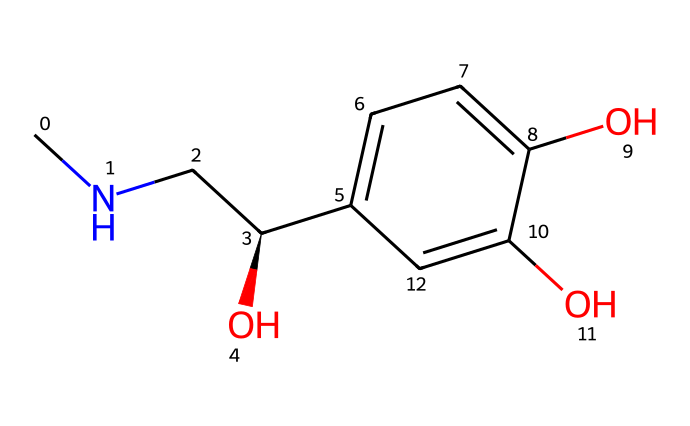What is the full name of this chiral compound? The chemical is adrenaline, also known as epinephrine, which is indicated by the presence of the amine group (CNC) and the hydroxyl groups on the aromatic ring.
Answer: adrenaline How many chiral centers are present in the chemical structure? The structure features one chiral center, which is marked by the carbon atom connected to the amine, hydroxyl, and neighboring carbon atoms (C[C@H]).
Answer: one What type of functional groups are present in this compound? The compound includes an alcohol (hydroxyl) group and an amine group, which are indicated by the –OH and –NH2 portions in the structure.
Answer: hydroxyl and amine What is the molecular formula derived from the structure? By analyzing the number of each atom present in the SMILES, we find it contains 9 carbons, 13 hydrogens, and 3 oxygens, leading to the formula C9H13O3.
Answer: C9H13O3 How many hydroxyl groups are attached to the aromatic ring? There are two hydroxyl groups present, as seen by the two –OH functionalities directly attached to the aromatic carbon ring (c1ccc).
Answer: two Is this compound optically active? Yes, it is optically active due to the presence of the chiral center (C[C@H]), which allows it to rotate plane-polarized light.
Answer: yes What role does adrenaline play during exciting moments in football matches? Adrenaline acts as a neurotransmitter that prepares the body for fight or flight responses, increasing heart rate and energy availability during exciting situations.
Answer: neurotransmitter 